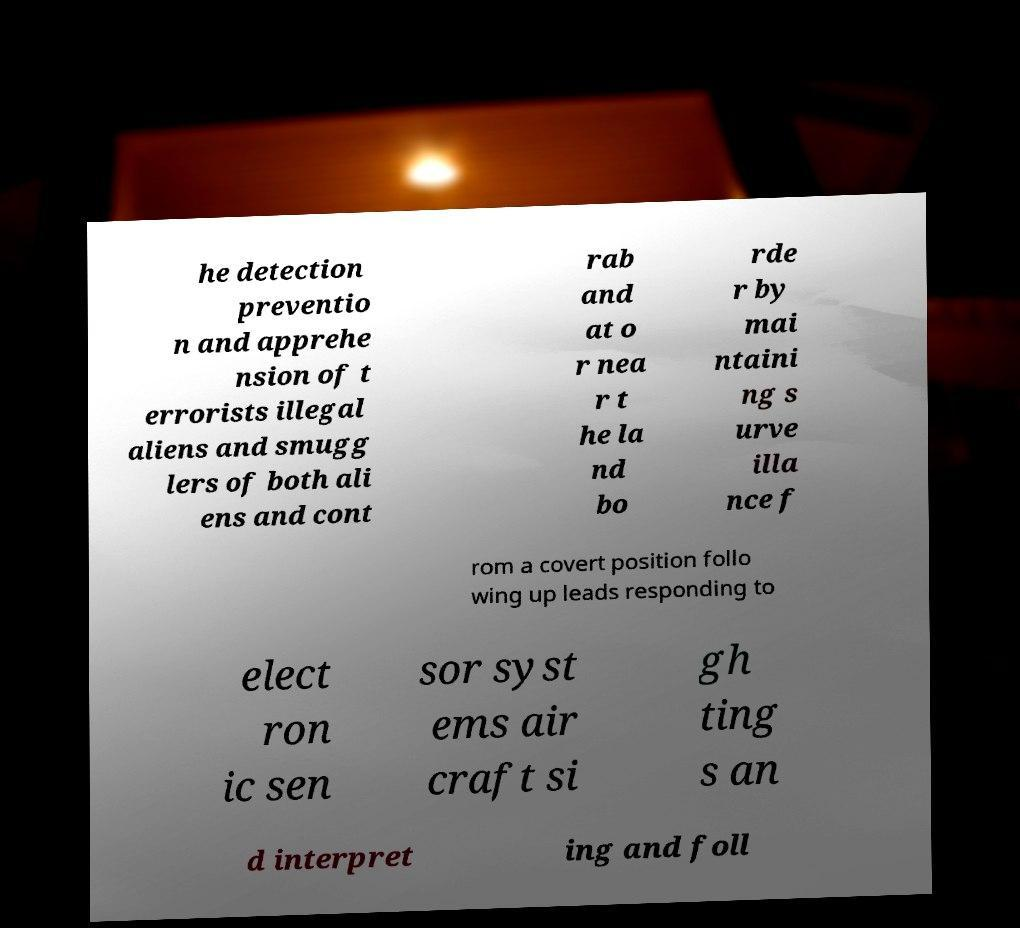Can you accurately transcribe the text from the provided image for me? he detection preventio n and apprehe nsion of t errorists illegal aliens and smugg lers of both ali ens and cont rab and at o r nea r t he la nd bo rde r by mai ntaini ng s urve illa nce f rom a covert position follo wing up leads responding to elect ron ic sen sor syst ems air craft si gh ting s an d interpret ing and foll 